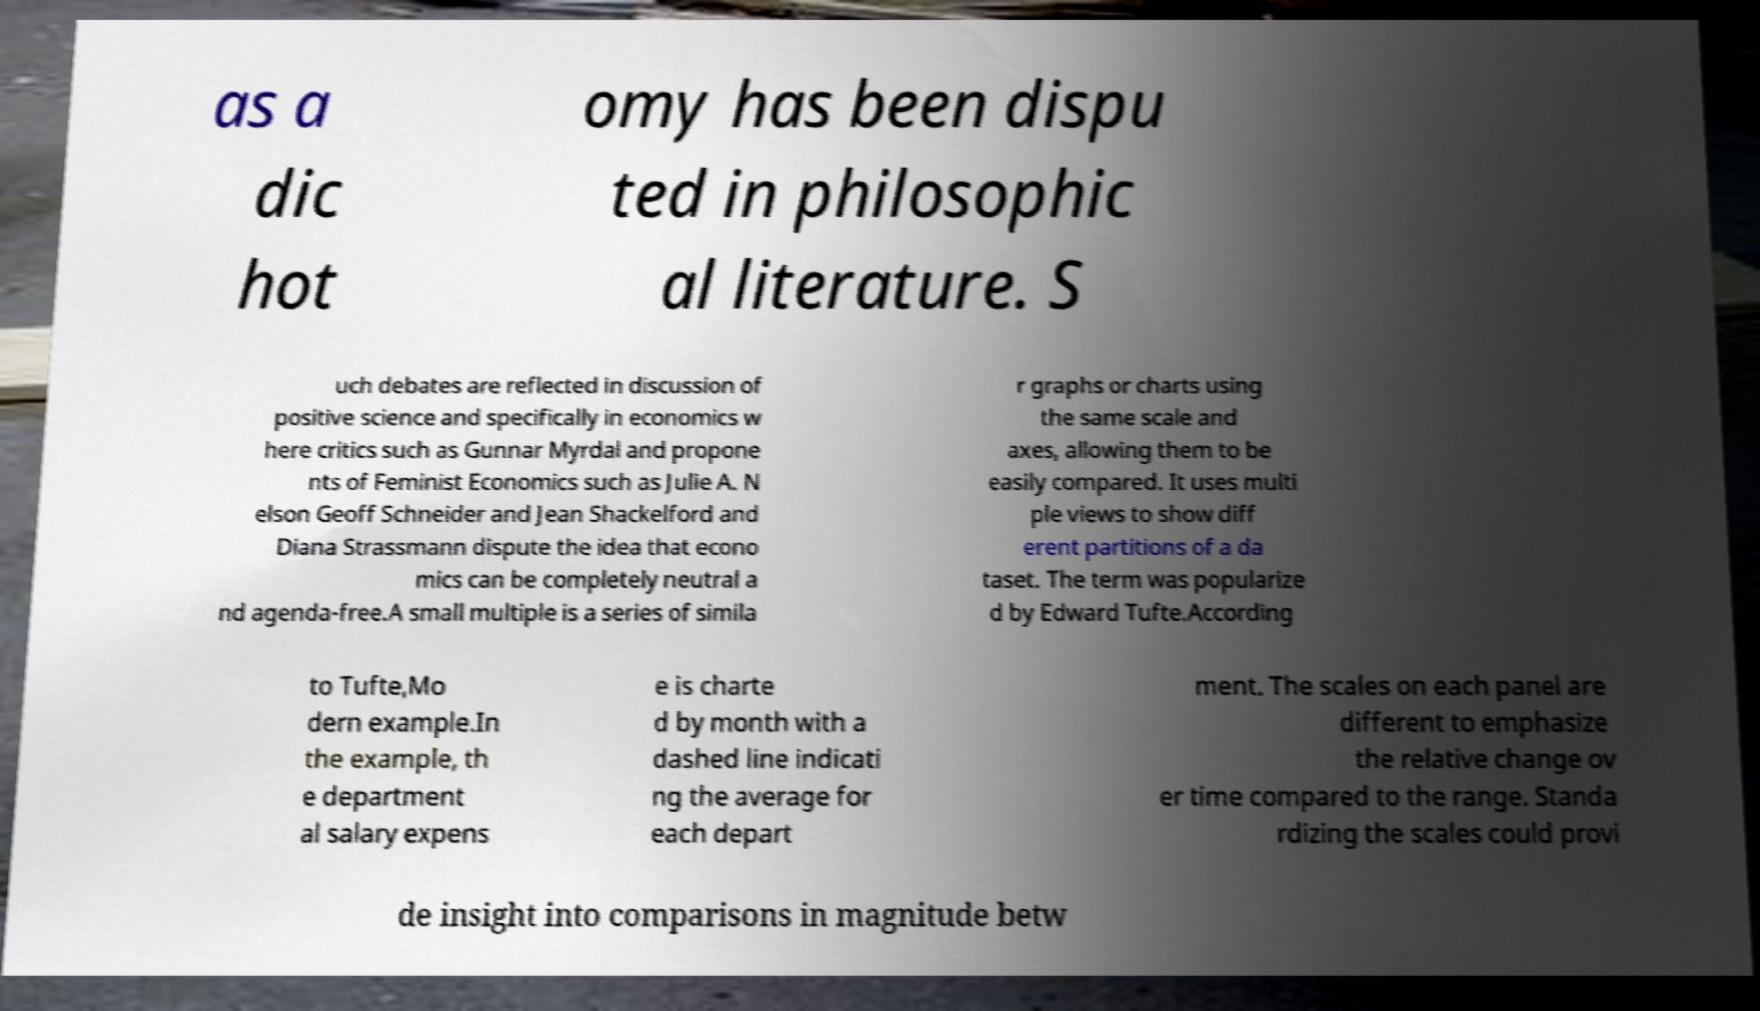For documentation purposes, I need the text within this image transcribed. Could you provide that? as a dic hot omy has been dispu ted in philosophic al literature. S uch debates are reflected in discussion of positive science and specifically in economics w here critics such as Gunnar Myrdal and propone nts of Feminist Economics such as Julie A. N elson Geoff Schneider and Jean Shackelford and Diana Strassmann dispute the idea that econo mics can be completely neutral a nd agenda-free.A small multiple is a series of simila r graphs or charts using the same scale and axes, allowing them to be easily compared. It uses multi ple views to show diff erent partitions of a da taset. The term was popularize d by Edward Tufte.According to Tufte,Mo dern example.In the example, th e department al salary expens e is charte d by month with a dashed line indicati ng the average for each depart ment. The scales on each panel are different to emphasize the relative change ov er time compared to the range. Standa rdizing the scales could provi de insight into comparisons in magnitude betw 